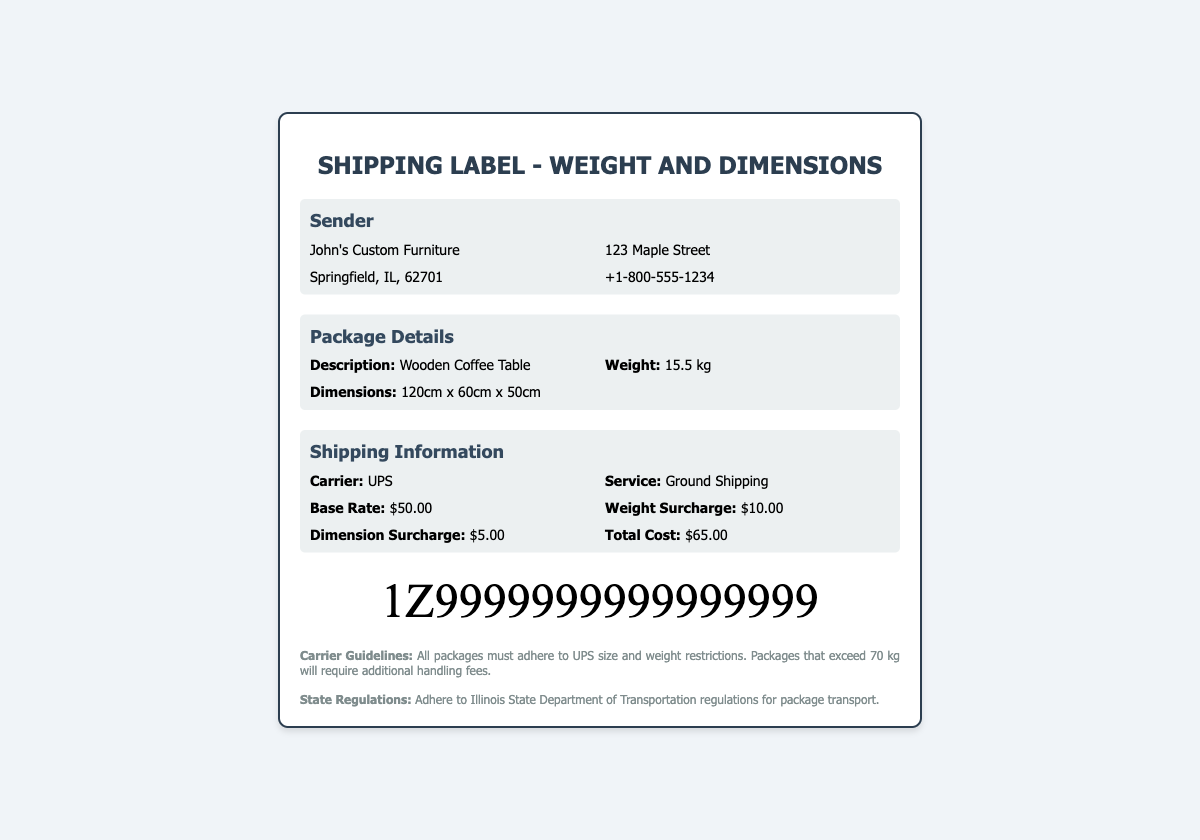What is the weight of the package? The package weight is specifically mentioned in the document as 15.5 kg.
Answer: 15.5 kg What are the package dimensions? The dimensions of the package are provided in the document as 120cm x 60cm x 50cm.
Answer: 120cm x 60cm x 50cm What is the total shipping cost? The total cost of shipping, including surcharges, is clearly stated as $65.00.
Answer: $65.00 What is the base rate for shipping? The base rate for shipping listed in the document is $50.00.
Answer: $50.00 What is the carrier for this shipment? The document specifies that UPS is the selected carrier for this shipment.
Answer: UPS Is there a surcharge for weight? The document lists a weight surcharge of $10.00.
Answer: $10.00 How many charges are listed in the shipping information? The shipping information details three charges: base rate, weight surcharge, and dimension surcharge.
Answer: Three What is the description of the package? The package is described in the document as a Wooden Coffee Table.
Answer: Wooden Coffee Table What is the compliance note regarding state regulations? The document advises to adhere to Illinois State Department of Transportation regulations for package transport.
Answer: Adhere to Illinois State Department of Transportation regulations for package transport 